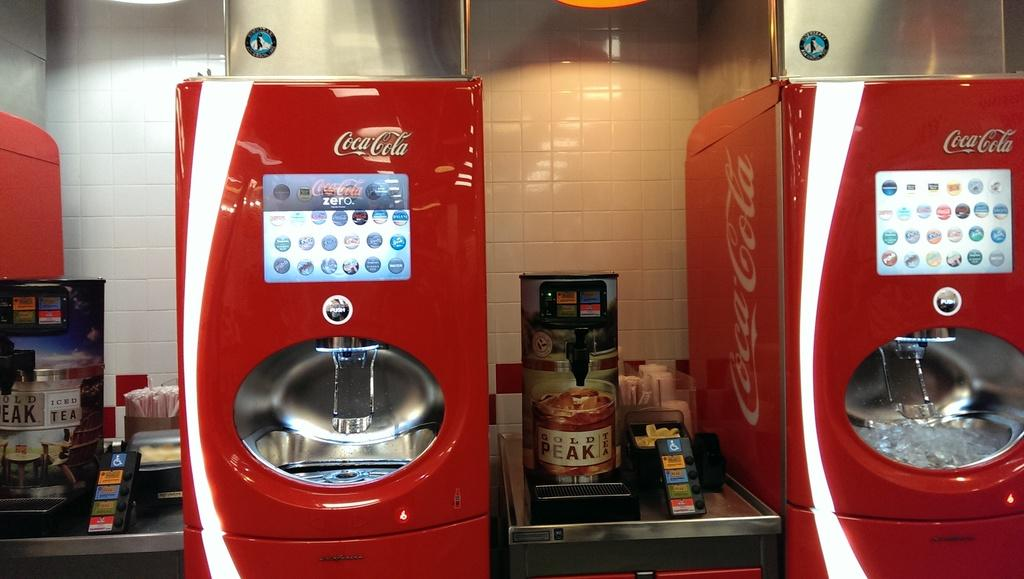What type of machines are present in the image? There are coke machines in the image. What can be seen in the background of the image? There is a wall in the background of the image. How many seeds are visible on the owl in the image? There is no owl present in the image, and therefore no seeds can be observed. 